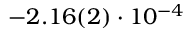<formula> <loc_0><loc_0><loc_500><loc_500>- 2 . 1 6 ( 2 ) \cdot 1 0 ^ { - 4 }</formula> 